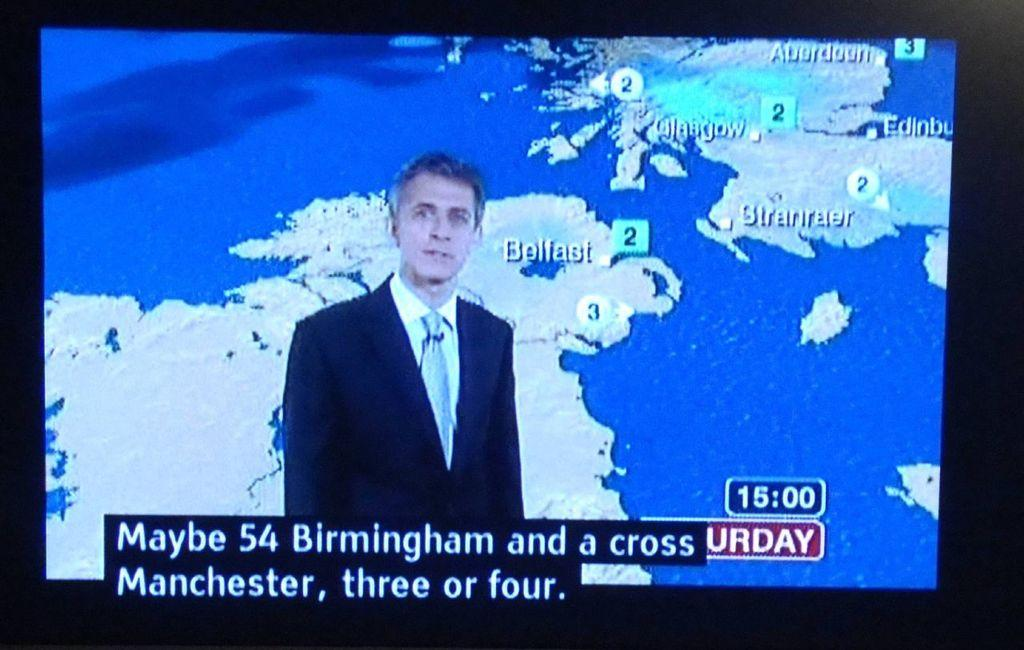What is the main subject of the image? There is a person in the image. What else can be seen in the image besides the person? There is text on a screen in the image. Is the person in the image using a swing to read the text on the screen? There is no swing present in the image, and the person is not using any device to read the text on the screen. 